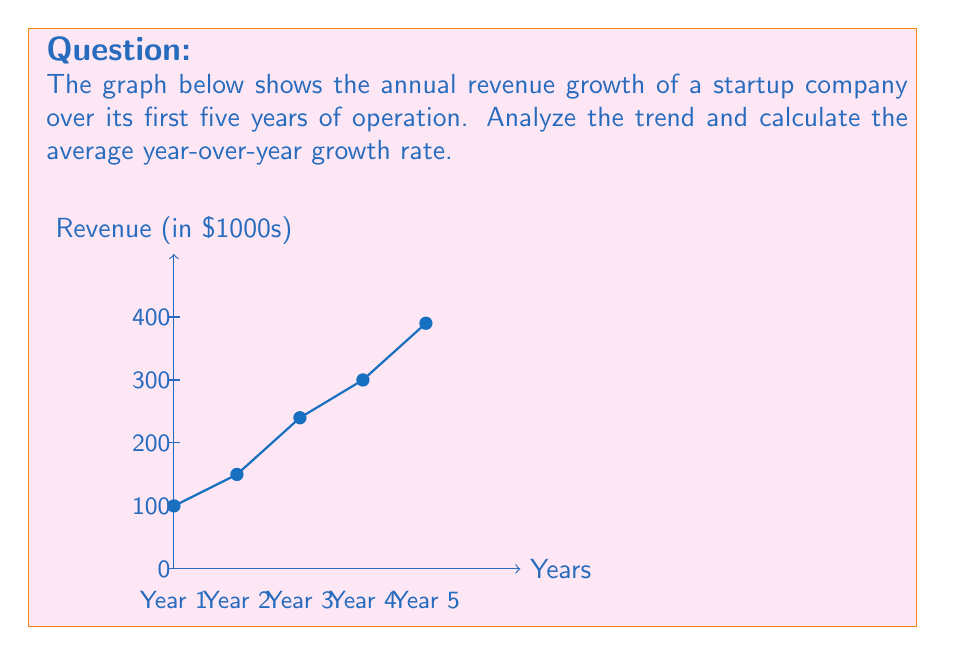Can you answer this question? To calculate the average year-over-year growth rate, we need to:

1. Calculate the growth rate for each year.
2. Take the average of these growth rates.

Let's calculate the growth rate for each year:

Year 1 to Year 2: 
$\frac{150 - 100}{100} = 0.50 = 50\%$

Year 2 to Year 3:
$\frac{240 - 150}{150} = 0.60 = 60\%$

Year 3 to Year 4:
$\frac{300 - 240}{240} = 0.25 = 25\%$

Year 4 to Year 5:
$\frac{390 - 300}{300} = 0.30 = 30\%$

Now, let's calculate the average of these growth rates:

$\frac{50\% + 60\% + 25\% + 30\%}{4} = \frac{165\%}{4} = 41.25\%$

Therefore, the average year-over-year growth rate is 41.25%.
Answer: 41.25% 